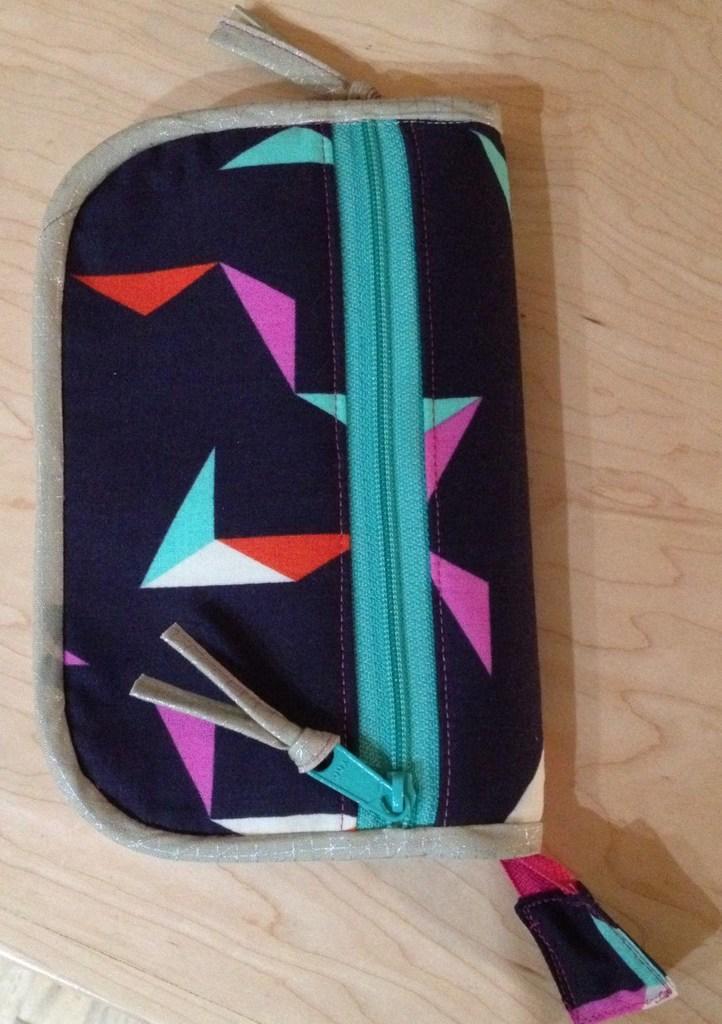How would you summarize this image in a sentence or two? In this image we can see one purse on the wooden table. 